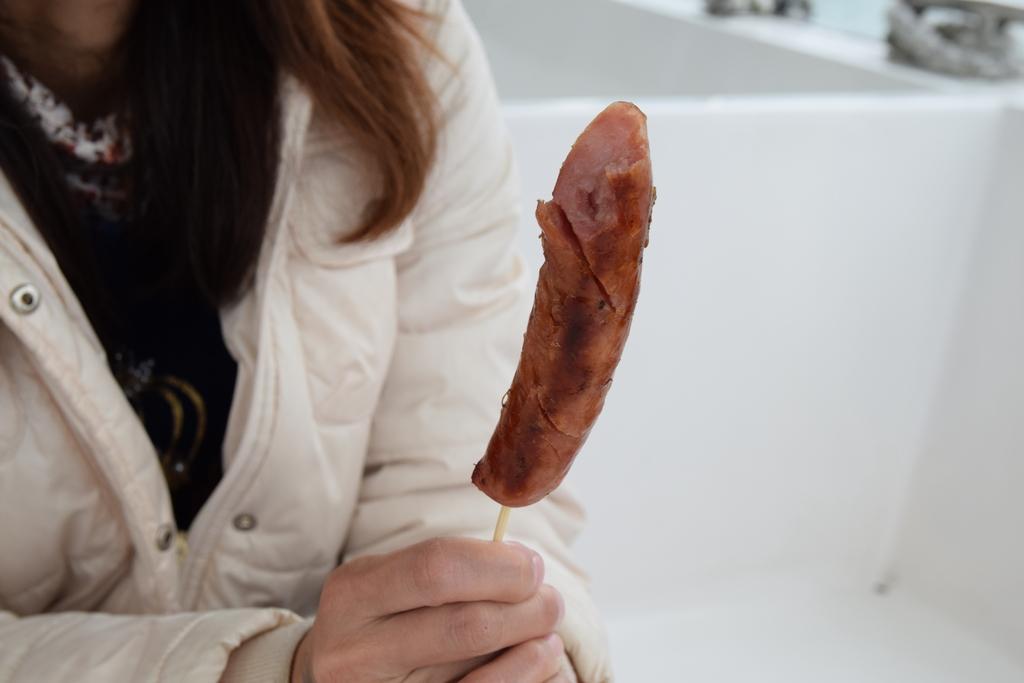Can you describe this image briefly? In this picture we can see a person, food and in the background we can see some objects and it is blurry. 